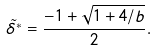Convert formula to latex. <formula><loc_0><loc_0><loc_500><loc_500>\tilde { \delta ^ { * } } = \frac { - 1 + \sqrt { 1 + 4 / b } } { 2 } .</formula> 